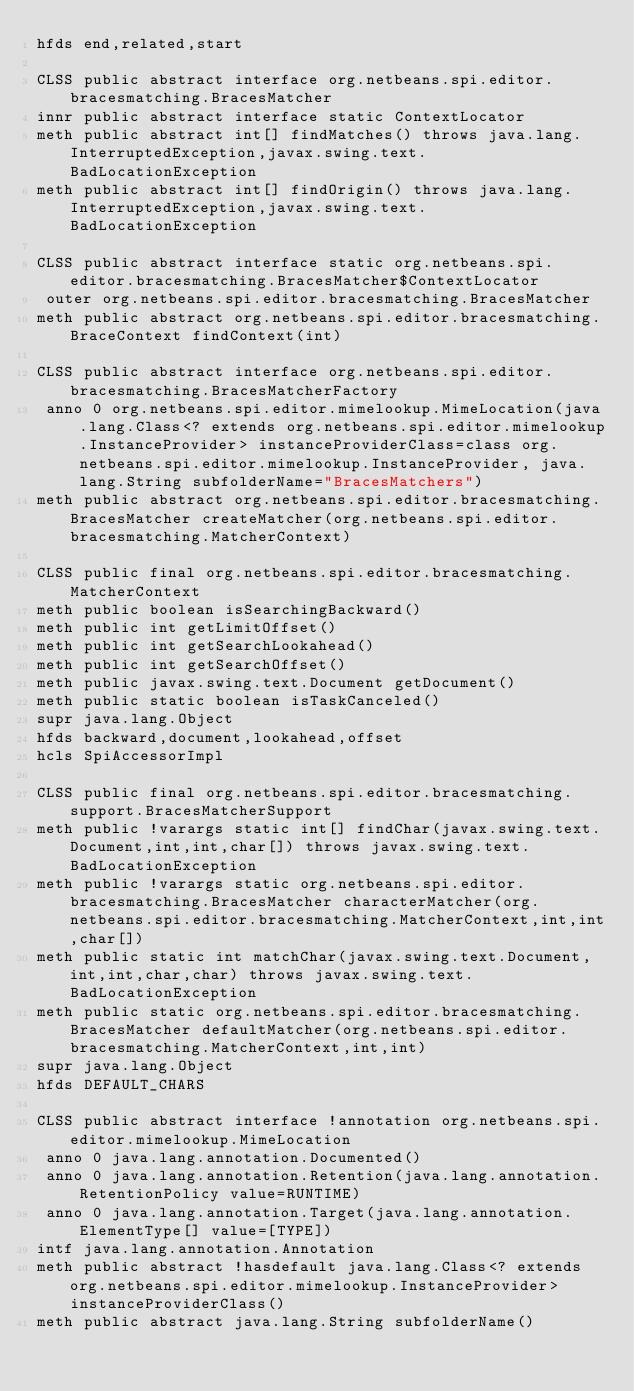<code> <loc_0><loc_0><loc_500><loc_500><_SML_>hfds end,related,start

CLSS public abstract interface org.netbeans.spi.editor.bracesmatching.BracesMatcher
innr public abstract interface static ContextLocator
meth public abstract int[] findMatches() throws java.lang.InterruptedException,javax.swing.text.BadLocationException
meth public abstract int[] findOrigin() throws java.lang.InterruptedException,javax.swing.text.BadLocationException

CLSS public abstract interface static org.netbeans.spi.editor.bracesmatching.BracesMatcher$ContextLocator
 outer org.netbeans.spi.editor.bracesmatching.BracesMatcher
meth public abstract org.netbeans.spi.editor.bracesmatching.BraceContext findContext(int)

CLSS public abstract interface org.netbeans.spi.editor.bracesmatching.BracesMatcherFactory
 anno 0 org.netbeans.spi.editor.mimelookup.MimeLocation(java.lang.Class<? extends org.netbeans.spi.editor.mimelookup.InstanceProvider> instanceProviderClass=class org.netbeans.spi.editor.mimelookup.InstanceProvider, java.lang.String subfolderName="BracesMatchers")
meth public abstract org.netbeans.spi.editor.bracesmatching.BracesMatcher createMatcher(org.netbeans.spi.editor.bracesmatching.MatcherContext)

CLSS public final org.netbeans.spi.editor.bracesmatching.MatcherContext
meth public boolean isSearchingBackward()
meth public int getLimitOffset()
meth public int getSearchLookahead()
meth public int getSearchOffset()
meth public javax.swing.text.Document getDocument()
meth public static boolean isTaskCanceled()
supr java.lang.Object
hfds backward,document,lookahead,offset
hcls SpiAccessorImpl

CLSS public final org.netbeans.spi.editor.bracesmatching.support.BracesMatcherSupport
meth public !varargs static int[] findChar(javax.swing.text.Document,int,int,char[]) throws javax.swing.text.BadLocationException
meth public !varargs static org.netbeans.spi.editor.bracesmatching.BracesMatcher characterMatcher(org.netbeans.spi.editor.bracesmatching.MatcherContext,int,int,char[])
meth public static int matchChar(javax.swing.text.Document,int,int,char,char) throws javax.swing.text.BadLocationException
meth public static org.netbeans.spi.editor.bracesmatching.BracesMatcher defaultMatcher(org.netbeans.spi.editor.bracesmatching.MatcherContext,int,int)
supr java.lang.Object
hfds DEFAULT_CHARS

CLSS public abstract interface !annotation org.netbeans.spi.editor.mimelookup.MimeLocation
 anno 0 java.lang.annotation.Documented()
 anno 0 java.lang.annotation.Retention(java.lang.annotation.RetentionPolicy value=RUNTIME)
 anno 0 java.lang.annotation.Target(java.lang.annotation.ElementType[] value=[TYPE])
intf java.lang.annotation.Annotation
meth public abstract !hasdefault java.lang.Class<? extends org.netbeans.spi.editor.mimelookup.InstanceProvider> instanceProviderClass()
meth public abstract java.lang.String subfolderName()

</code> 